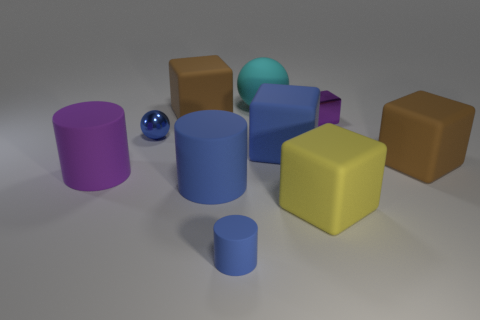There is a tiny purple metallic object; does it have the same shape as the big brown rubber thing that is in front of the purple shiny thing?
Keep it short and to the point. Yes. What is the color of the small thing that is both left of the large yellow rubber cube and behind the yellow matte thing?
Make the answer very short. Blue. Are there any other things of the same shape as the purple rubber thing?
Keep it short and to the point. Yes. Does the metal sphere have the same color as the small rubber object?
Provide a succinct answer. Yes. Is there a tiny rubber cylinder that is in front of the big brown object left of the small blue cylinder?
Offer a terse response. Yes. What number of objects are either blue objects that are left of the big cyan rubber thing or purple objects right of the big blue block?
Keep it short and to the point. 4. What number of objects are either red matte balls or blue rubber things that are left of the big cyan rubber sphere?
Give a very brief answer. 2. How big is the metallic thing left of the big brown matte object behind the brown thing in front of the small blue metal object?
Your answer should be very brief. Small. What is the material of the purple object that is the same size as the metal ball?
Offer a terse response. Metal. Is there a brown block of the same size as the cyan object?
Offer a terse response. Yes. 